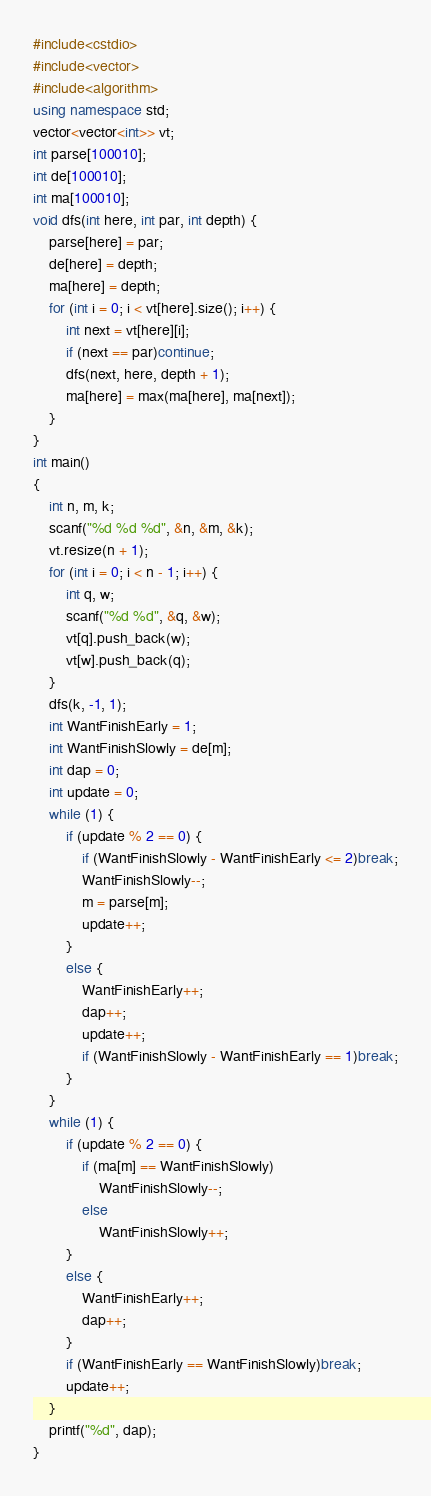Convert code to text. <code><loc_0><loc_0><loc_500><loc_500><_C++_>#include<cstdio>
#include<vector>
#include<algorithm>
using namespace std;
vector<vector<int>> vt;
int parse[100010];
int de[100010];
int ma[100010];
void dfs(int here, int par, int depth) {
	parse[here] = par;
	de[here] = depth;
	ma[here] = depth;
	for (int i = 0; i < vt[here].size(); i++) {
		int next = vt[here][i];
		if (next == par)continue;
		dfs(next, here, depth + 1);
		ma[here] = max(ma[here], ma[next]);
	}
}
int main()
{
	int n, m, k;
	scanf("%d %d %d", &n, &m, &k);
	vt.resize(n + 1);
	for (int i = 0; i < n - 1; i++) {
		int q, w;
		scanf("%d %d", &q, &w);
		vt[q].push_back(w);
		vt[w].push_back(q);
	}
	dfs(k, -1, 1);
	int WantFinishEarly = 1;
	int WantFinishSlowly = de[m];
	int dap = 0;
	int update = 0;
	while (1) {
		if (update % 2 == 0) {
			if (WantFinishSlowly - WantFinishEarly <= 2)break;
			WantFinishSlowly--;
			m = parse[m];
			update++;
		}
		else {
			WantFinishEarly++;
			dap++;
			update++;
			if (WantFinishSlowly - WantFinishEarly == 1)break;
		}
	}
	while (1) {
		if (update % 2 == 0) {
			if (ma[m] == WantFinishSlowly)
				WantFinishSlowly--;
			else
				WantFinishSlowly++;
		}
		else {
			WantFinishEarly++;
			dap++;
		}
		if (WantFinishEarly == WantFinishSlowly)break;
		update++;
	}
	printf("%d", dap);
}</code> 